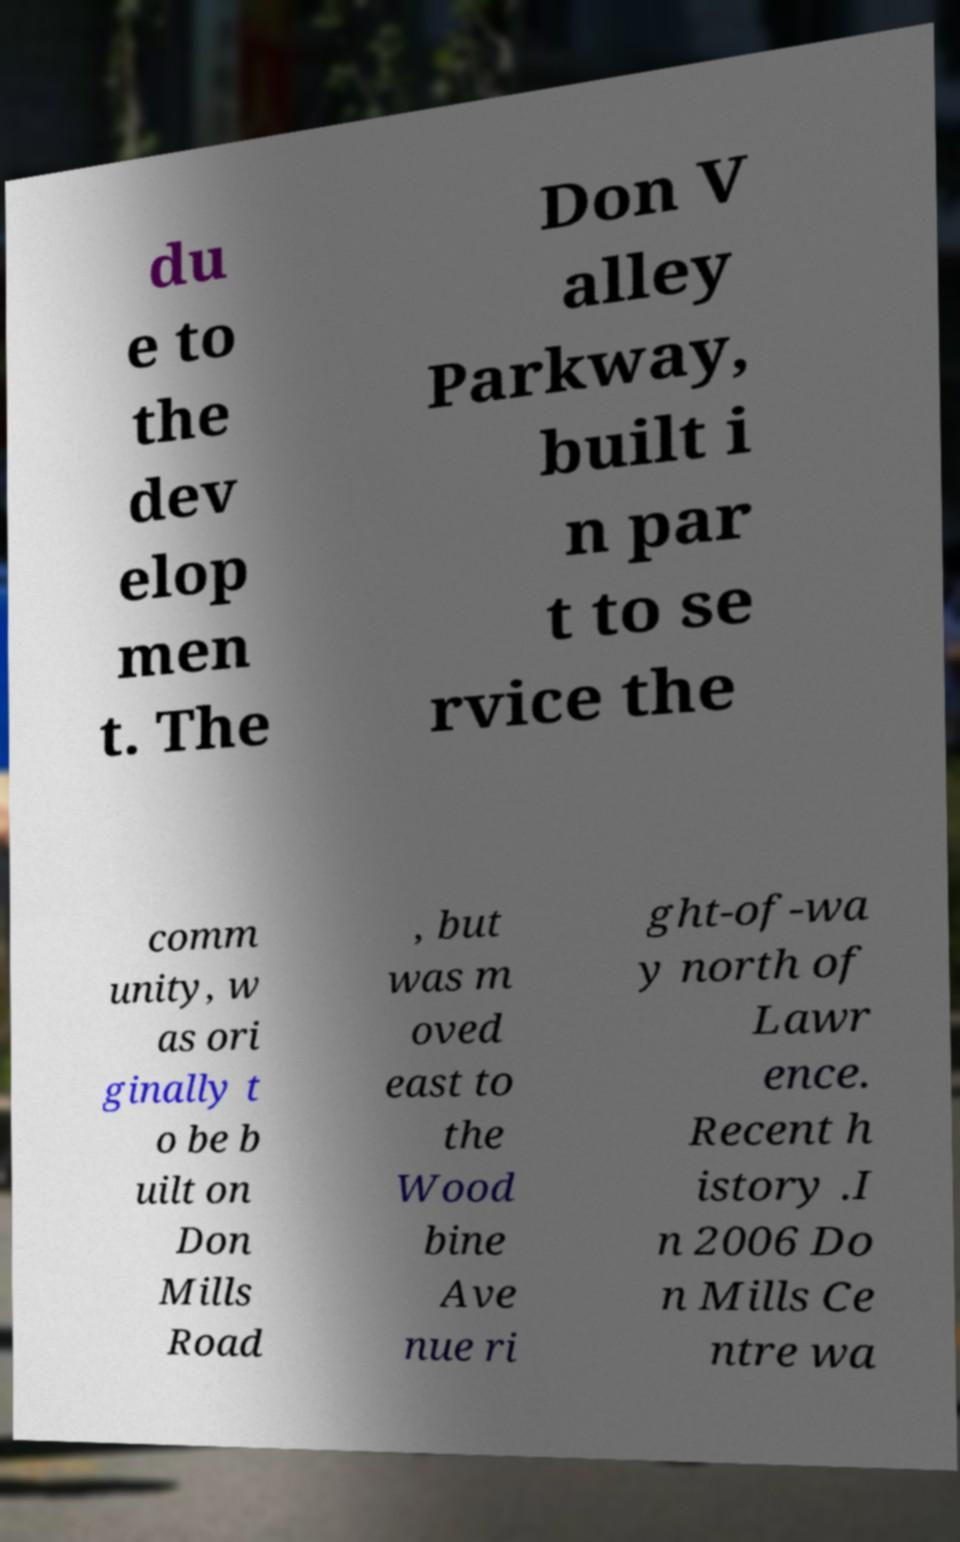I need the written content from this picture converted into text. Can you do that? du e to the dev elop men t. The Don V alley Parkway, built i n par t to se rvice the comm unity, w as ori ginally t o be b uilt on Don Mills Road , but was m oved east to the Wood bine Ave nue ri ght-of-wa y north of Lawr ence. Recent h istory .I n 2006 Do n Mills Ce ntre wa 